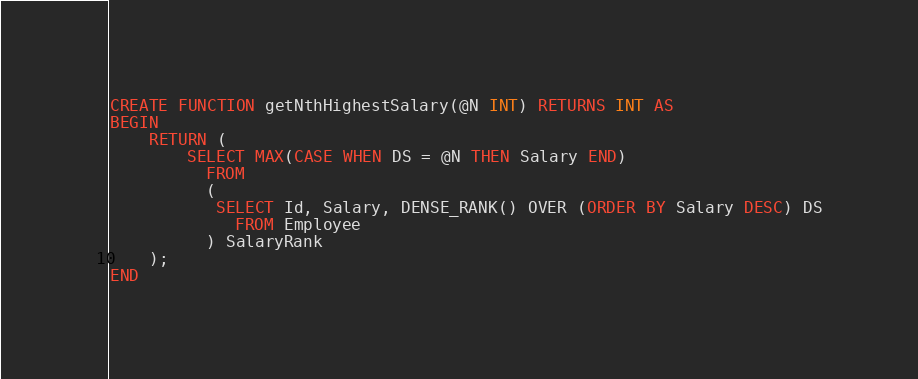Convert code to text. <code><loc_0><loc_0><loc_500><loc_500><_SQL_>CREATE FUNCTION getNthHighestSalary(@N INT) RETURNS INT AS
BEGIN
    RETURN (
        SELECT MAX(CASE WHEN DS = @N THEN Salary END)
          FROM 
          (
           SELECT Id, Salary, DENSE_RANK() OVER (ORDER BY Salary DESC) DS
             FROM Employee
          ) SalaryRank
    );
END
</code> 